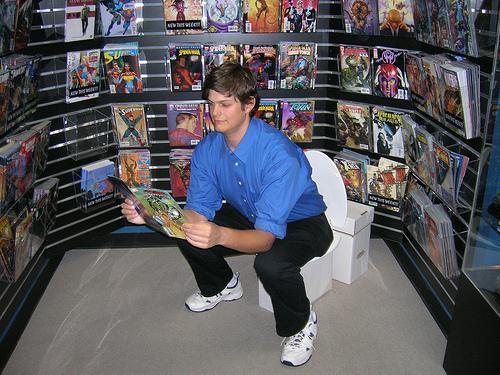How many people are there?
Give a very brief answer. 1. 